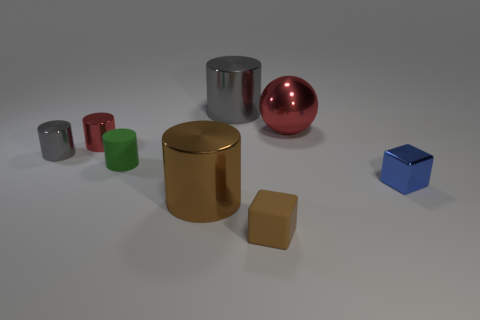Subtract all tiny cylinders. How many cylinders are left? 2 Subtract all blue cubes. How many cubes are left? 1 Subtract 1 blocks. How many blocks are left? 1 Add 2 large cyan metal cylinders. How many objects exist? 10 Subtract all red blocks. How many gray cylinders are left? 2 Subtract all spheres. How many objects are left? 7 Subtract all blue cubes. Subtract all green balls. How many cubes are left? 1 Subtract all small brown metal things. Subtract all tiny blue things. How many objects are left? 7 Add 1 tiny green things. How many tiny green things are left? 2 Add 7 brown matte blocks. How many brown matte blocks exist? 8 